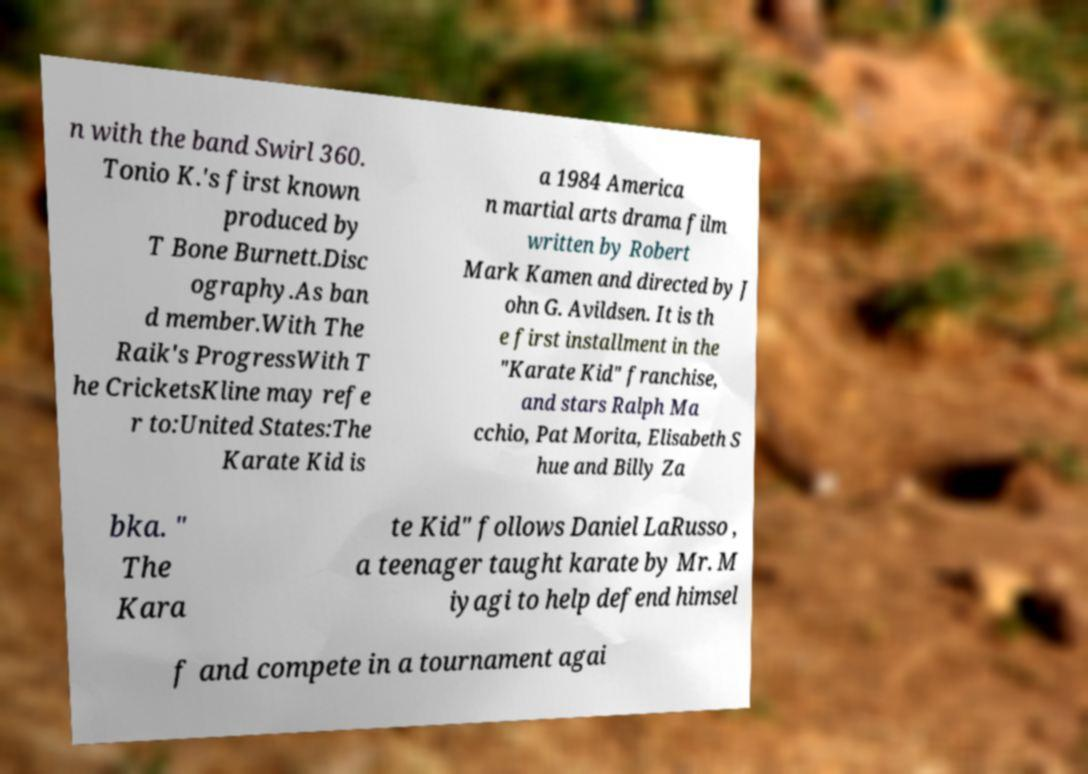Can you read and provide the text displayed in the image?This photo seems to have some interesting text. Can you extract and type it out for me? n with the band Swirl 360. Tonio K.'s first known produced by T Bone Burnett.Disc ography.As ban d member.With The Raik's ProgressWith T he CricketsKline may refe r to:United States:The Karate Kid is a 1984 America n martial arts drama film written by Robert Mark Kamen and directed by J ohn G. Avildsen. It is th e first installment in the "Karate Kid" franchise, and stars Ralph Ma cchio, Pat Morita, Elisabeth S hue and Billy Za bka. " The Kara te Kid" follows Daniel LaRusso , a teenager taught karate by Mr. M iyagi to help defend himsel f and compete in a tournament agai 